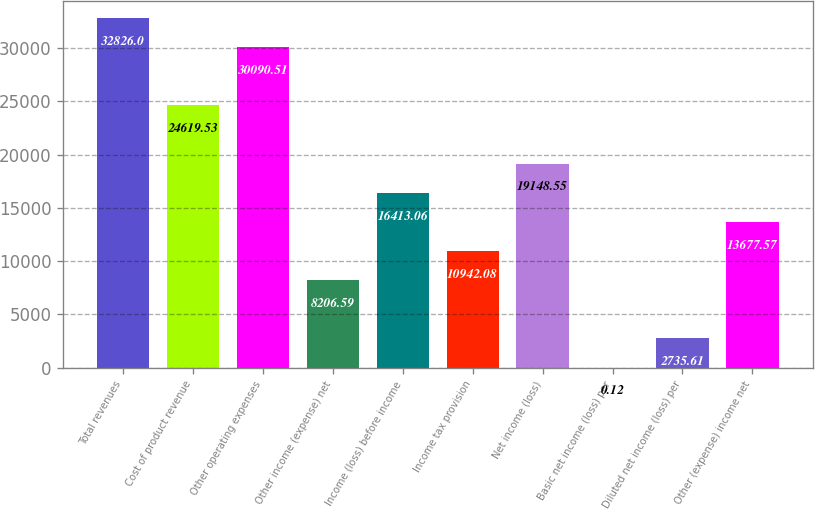Convert chart. <chart><loc_0><loc_0><loc_500><loc_500><bar_chart><fcel>Total revenues<fcel>Cost of product revenue<fcel>Other operating expenses<fcel>Other income (expense) net<fcel>Income (loss) before income<fcel>Income tax provision<fcel>Net income (loss)<fcel>Basic net income (loss) per<fcel>Diluted net income (loss) per<fcel>Other (expense) income net<nl><fcel>32826<fcel>24619.5<fcel>30090.5<fcel>8206.59<fcel>16413.1<fcel>10942.1<fcel>19148.5<fcel>0.12<fcel>2735.61<fcel>13677.6<nl></chart> 